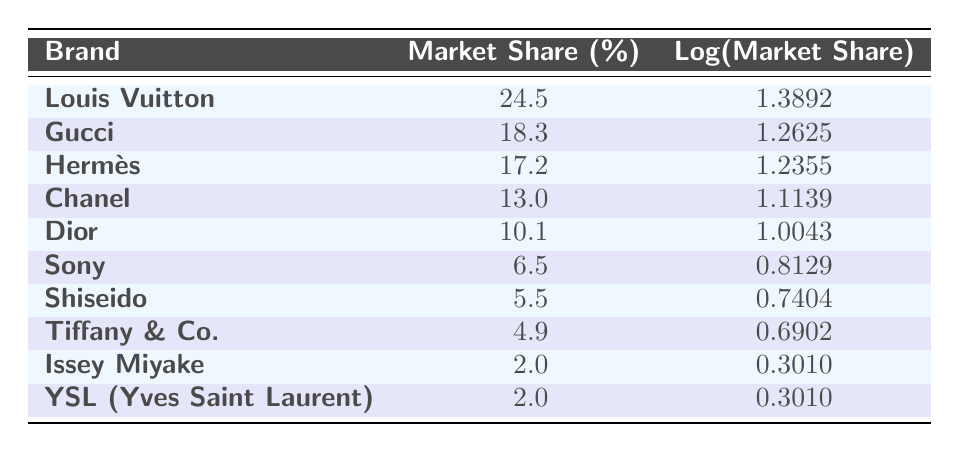What's the market share of Louis Vuitton? The table lists Louis Vuitton with a market share percentage of 24.5%. This value can be directly retrieved from the corresponding row in the table.
Answer: 24.5% Which brand has the lowest market share? The table shows that Issey Miyake and YSL (Yves Saint Laurent) both have a market share percentage of 2.0%, making them the brands with the lowest market share. This conclusion is based on comparing the market share percentages in the table.
Answer: Issey Miyake and YSL (Yves Saint Laurent) What is the total market share of the top three brands? The top three brands are Louis Vuitton (24.5%), Gucci (18.3%), and Hermès (17.2%). Summing their market shares gives 24.5 + 18.3 + 17.2 = 60.0. Therefore, the total market share of the top three is 60.0%.
Answer: 60.0% Is the market share of Shiseido greater than that of Tiffany & Co.? The table indicates Shiseido has a market share of 5.5% while Tiffany & Co. has 4.9%. Since 5.5% is greater than 4.9%, the statement is true.
Answer: Yes What is the average market share of the Japanese brands listed? The Japanese brands are Sony (6.5%), Shiseido (5.5%), Issey Miyake (2.0%), and YSL (2.0%). Their total market share is 6.5 + 5.5 + 2.0 + 2.0 = 16.0%. With four brands, the average is 16.0% / 4 = 4.0%.
Answer: 4.0% 